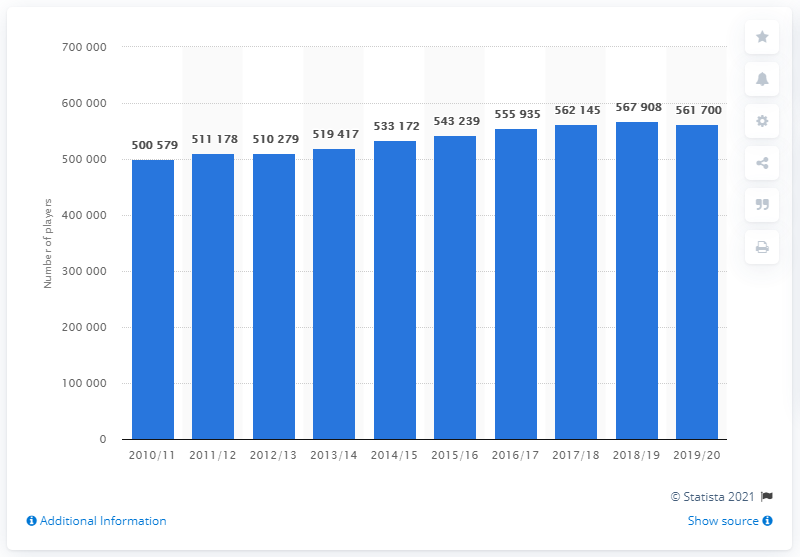Identify some key points in this picture. The average height of the tallest and shortest blue bars is approximately 531139.5. In the year 2014/15, the increase in the number of registered ice hockey players was the greatest. 